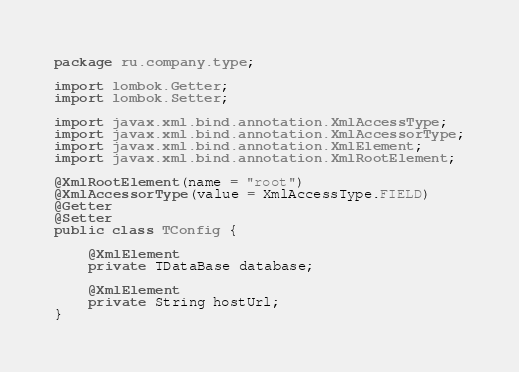Convert code to text. <code><loc_0><loc_0><loc_500><loc_500><_Java_>package ru.company.type;

import lombok.Getter;
import lombok.Setter;

import javax.xml.bind.annotation.XmlAccessType;
import javax.xml.bind.annotation.XmlAccessorType;
import javax.xml.bind.annotation.XmlElement;
import javax.xml.bind.annotation.XmlRootElement;

@XmlRootElement(name = "root")
@XmlAccessorType(value = XmlAccessType.FIELD)
@Getter
@Setter
public class TConfig {

    @XmlElement
    private TDataBase database;

    @XmlElement
    private String hostUrl;
}
</code> 